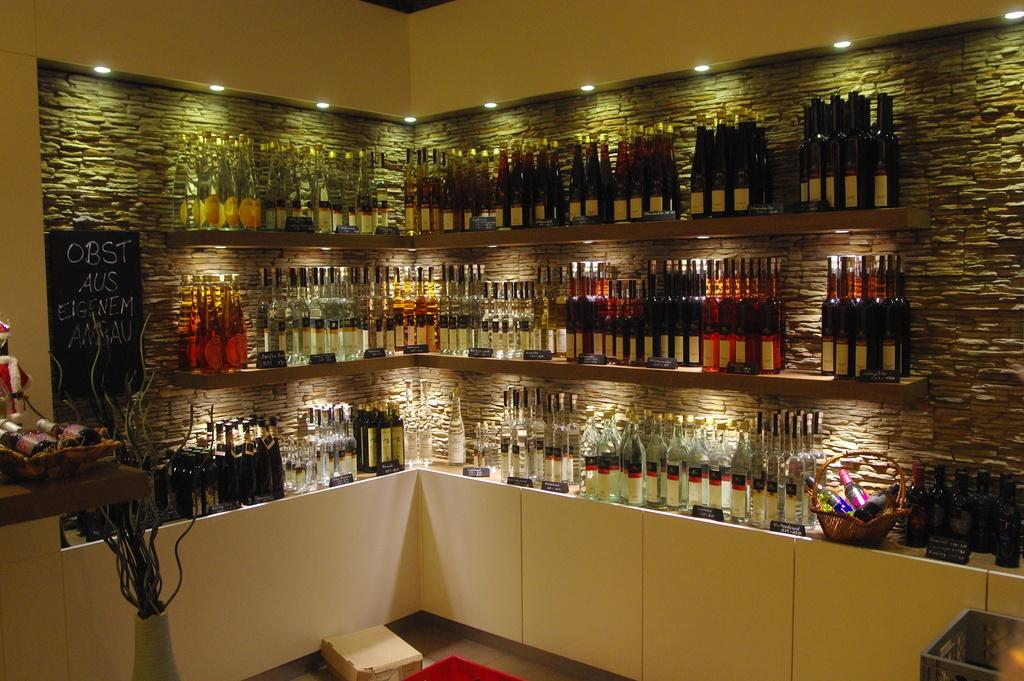What can be seen on the shelves in the image? There are bottles on the shelves in the image. What is located near the shelves in the image? There is a basket in the image. What is on the table in the image? There are objects on the table in the image. What provides illumination in the image? There are lights in the image. What can be used for displaying information or messages in the image? There is a board in the image. Can you see a squirrel climbing the board in the image? There is no squirrel present in the image. How much friction is there between the objects on the table in the image? The amount of friction between the objects on the table cannot be determined from the image alone. 